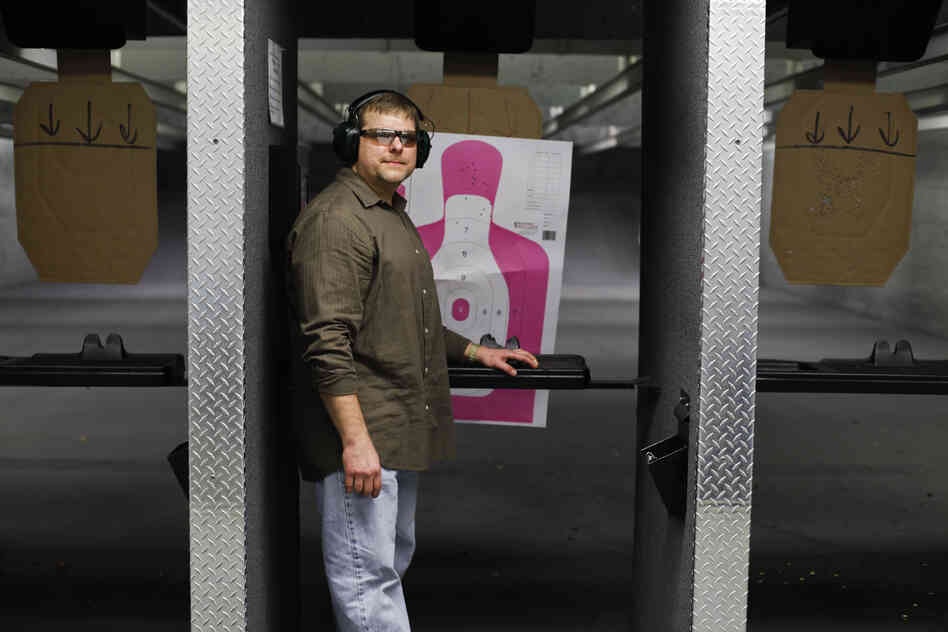What might the human above be thinking about as he prepares to shoot? The person in the image might be focused on several thoughts as he prepares to shoot. He could be concentrating on his stance, grip, and breathing, ensuring that each aspect is optimal for accuracy. He might be recalling previous sessions, thinking about past mistakes and how to correct them. The presence of the different target zones could be making him plan his shots, deciding which areas to focus on based on his current skill level and goals.

There may also be an element of excitement and anticipation, especially if he’s challenging himself with new drills or techniques. If he’s training for a specific purpose, such as a competition or personal defense, his mind might be running through various scenarios, making him more determined and focused. Overall, his thoughts are likely centered on technique, improvement, and the satisfying results of hitting his targets accurately. 